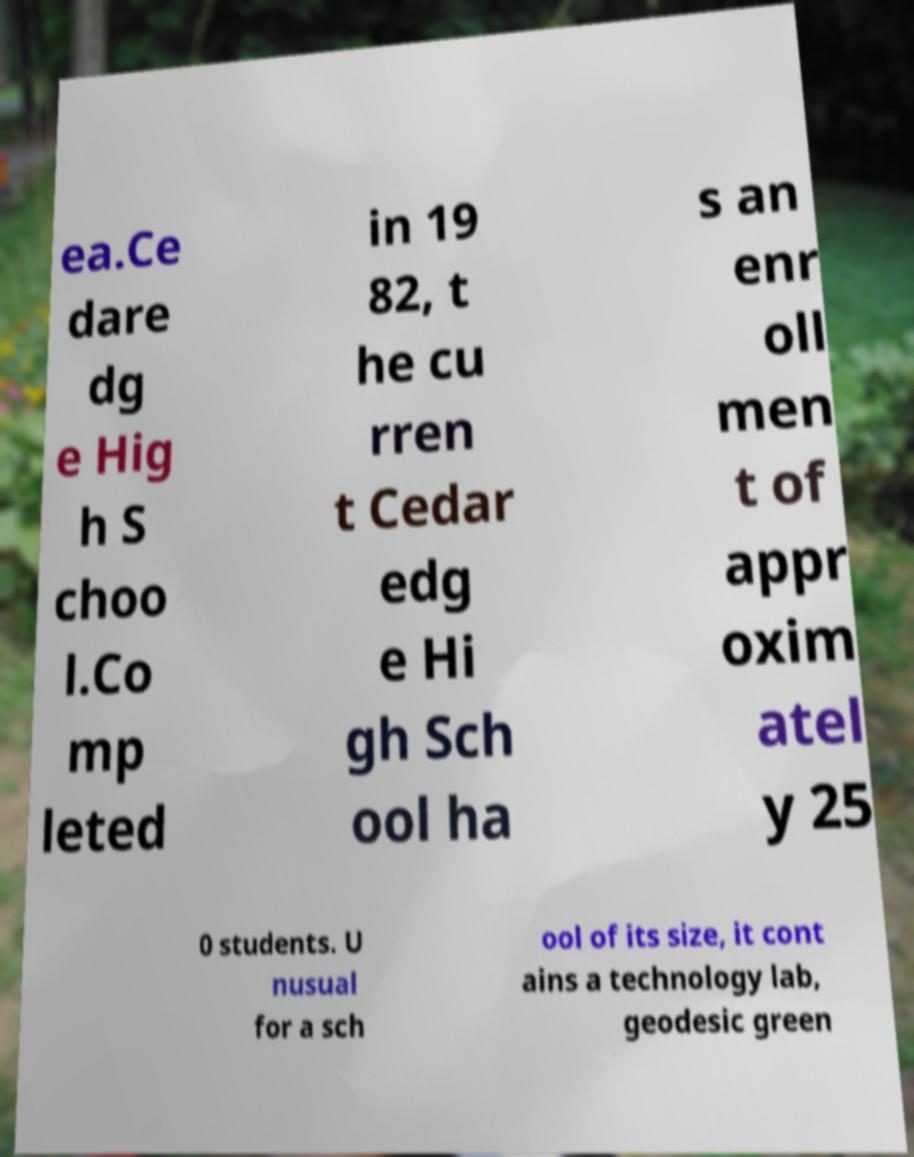For documentation purposes, I need the text within this image transcribed. Could you provide that? ea.Ce dare dg e Hig h S choo l.Co mp leted in 19 82, t he cu rren t Cedar edg e Hi gh Sch ool ha s an enr oll men t of appr oxim atel y 25 0 students. U nusual for a sch ool of its size, it cont ains a technology lab, geodesic green 